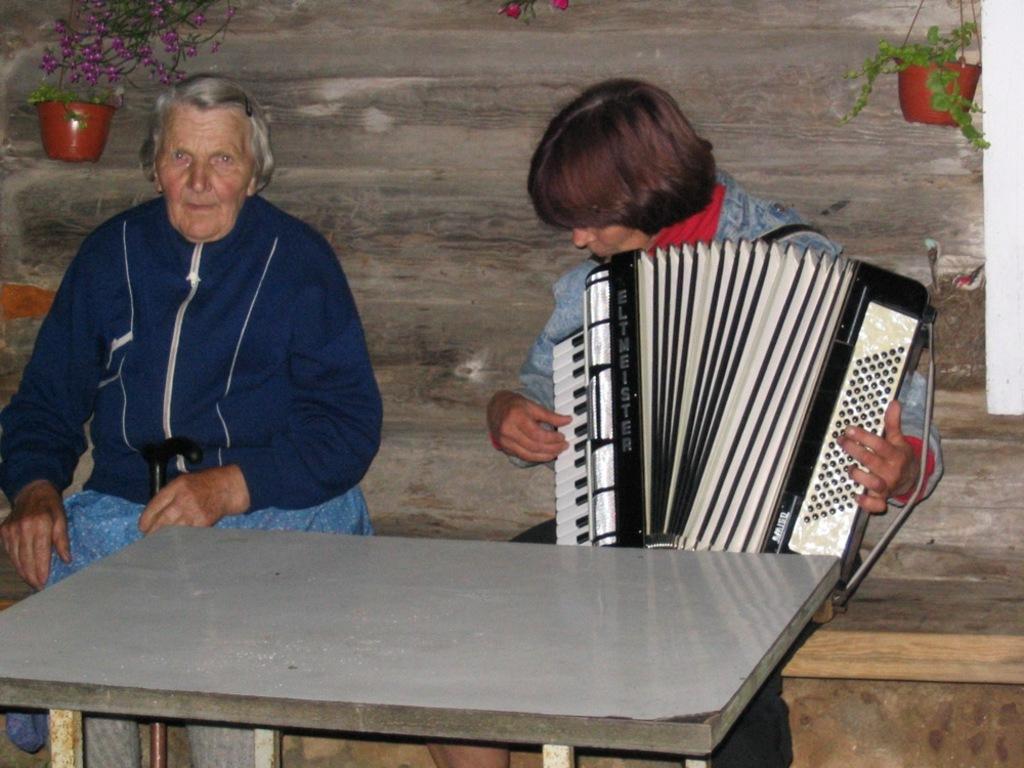Describe this image in one or two sentences. In the center of the image a man is sitting and playing garmon. On the left side of the image a person is sitting. In the middle of the image a table is there. In the background of the image we can see flower pots, wall are there. 